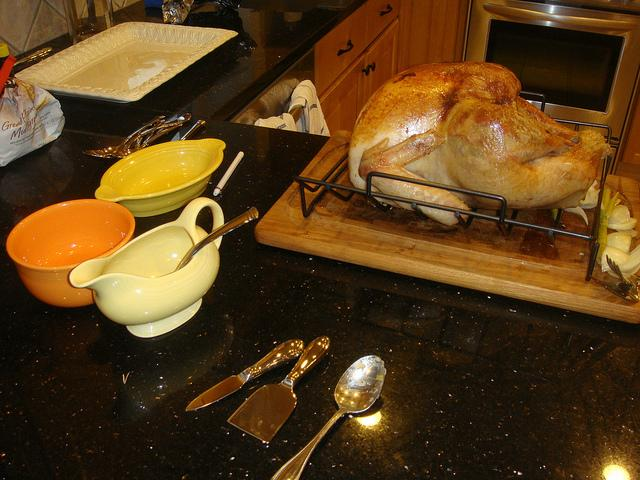What type of animal is being prepared? turkey 